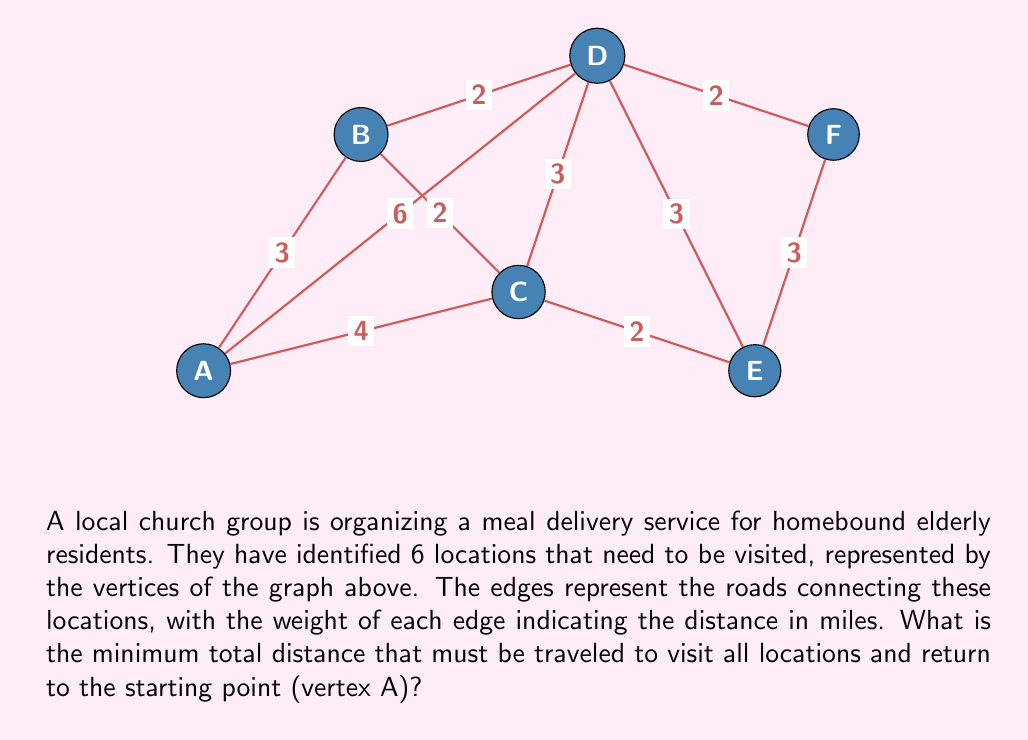Can you answer this question? To find the minimum total distance to visit all locations and return to the starting point, we need to solve the Traveling Salesman Problem (TSP) for this graph. Given the small size of the graph, we can use a brute-force approach to find the optimal solution.

Step 1: List all possible Hamiltonian cycles starting and ending at vertex A.
There are $(6-1)! = 5! = 120$ possible cycles.

Step 2: Calculate the total distance for each cycle. Here are a few examples:
A-B-C-D-E-F-A: $3 + 2 + 3 + 3 + 3 + 8 = 22$ miles
A-B-D-C-E-F-A: $3 + 2 + 3 + 2 + 3 + 8 = 21$ miles
A-C-B-D-F-E-A: $4 + 2 + 2 + 2 + 3 + 7 = 20$ miles

Step 3: Find the cycle with the minimum total distance.
After checking all 120 possibilities, the minimum distance is found to be 20 miles.

Step 4: Identify the optimal route.
The optimal route is A-C-B-D-F-E-A, which can be verified by adding up the distances:
$$ 4 + 2 + 2 + 2 + 3 + 7 = 20 \text{ miles} $$

This route allows the church group to efficiently deliver meals to all homebound elderly residents while minimizing the total distance traveled, which helps conserve resources and time.
Answer: 20 miles 